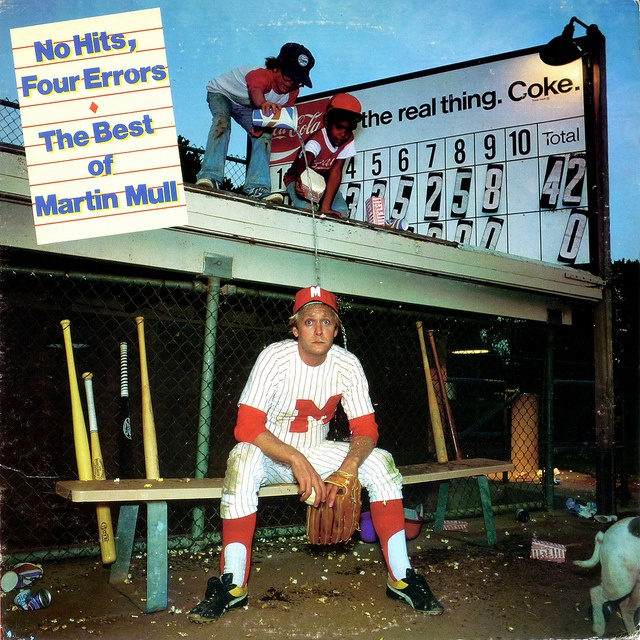Describe the objects in this image and their specific colors. I can see people in darkgray, white, black, brown, and red tones, bench in darkgray, black, khaki, olive, and teal tones, people in darkgray, black, blue, gray, and maroon tones, dog in darkgray, gray, black, teal, and turquoise tones, and people in darkgray, black, maroon, brown, and lavender tones in this image. 